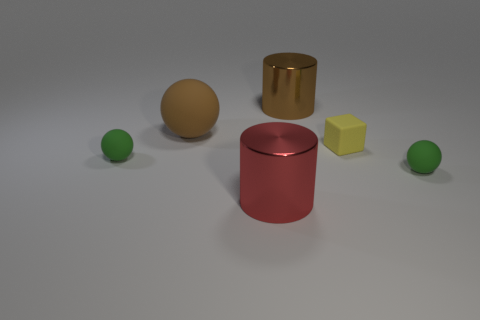What size is the cylinder that is the same color as the large sphere?
Your answer should be very brief. Large. What color is the other metallic thing that is the same shape as the large red thing?
Ensure brevity in your answer.  Brown. What number of small things are brown objects or yellow blocks?
Give a very brief answer. 1. Are the tiny yellow cube and the large brown sphere made of the same material?
Your answer should be very brief. Yes. How many small yellow things are to the left of the large matte thing behind the large red cylinder?
Keep it short and to the point. 0. Is there another tiny rubber thing that has the same shape as the brown rubber object?
Keep it short and to the point. Yes. There is a green thing that is to the left of the big brown cylinder; is it the same shape as the green object that is right of the brown matte object?
Give a very brief answer. Yes. What shape is the big object that is both in front of the big brown metal thing and right of the brown matte sphere?
Make the answer very short. Cylinder. Is there another brown rubber sphere of the same size as the brown matte sphere?
Ensure brevity in your answer.  No. There is a large rubber thing; is it the same color as the big shiny object right of the red thing?
Provide a succinct answer. Yes. 